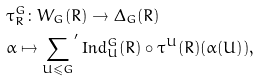Convert formula to latex. <formula><loc_0><loc_0><loc_500><loc_500>& \tau _ { R } ^ { G } \colon W _ { G } ( R ) \to \Delta _ { G } ( R ) \\ & \alpha \mapsto { \underset { U \leqslant G } { \sum } ^ { \prime } } \, \text {Ind} _ { U } ^ { G } ( R ) \circ \tau ^ { U } ( R ) ( \alpha ( U ) ) ,</formula> 